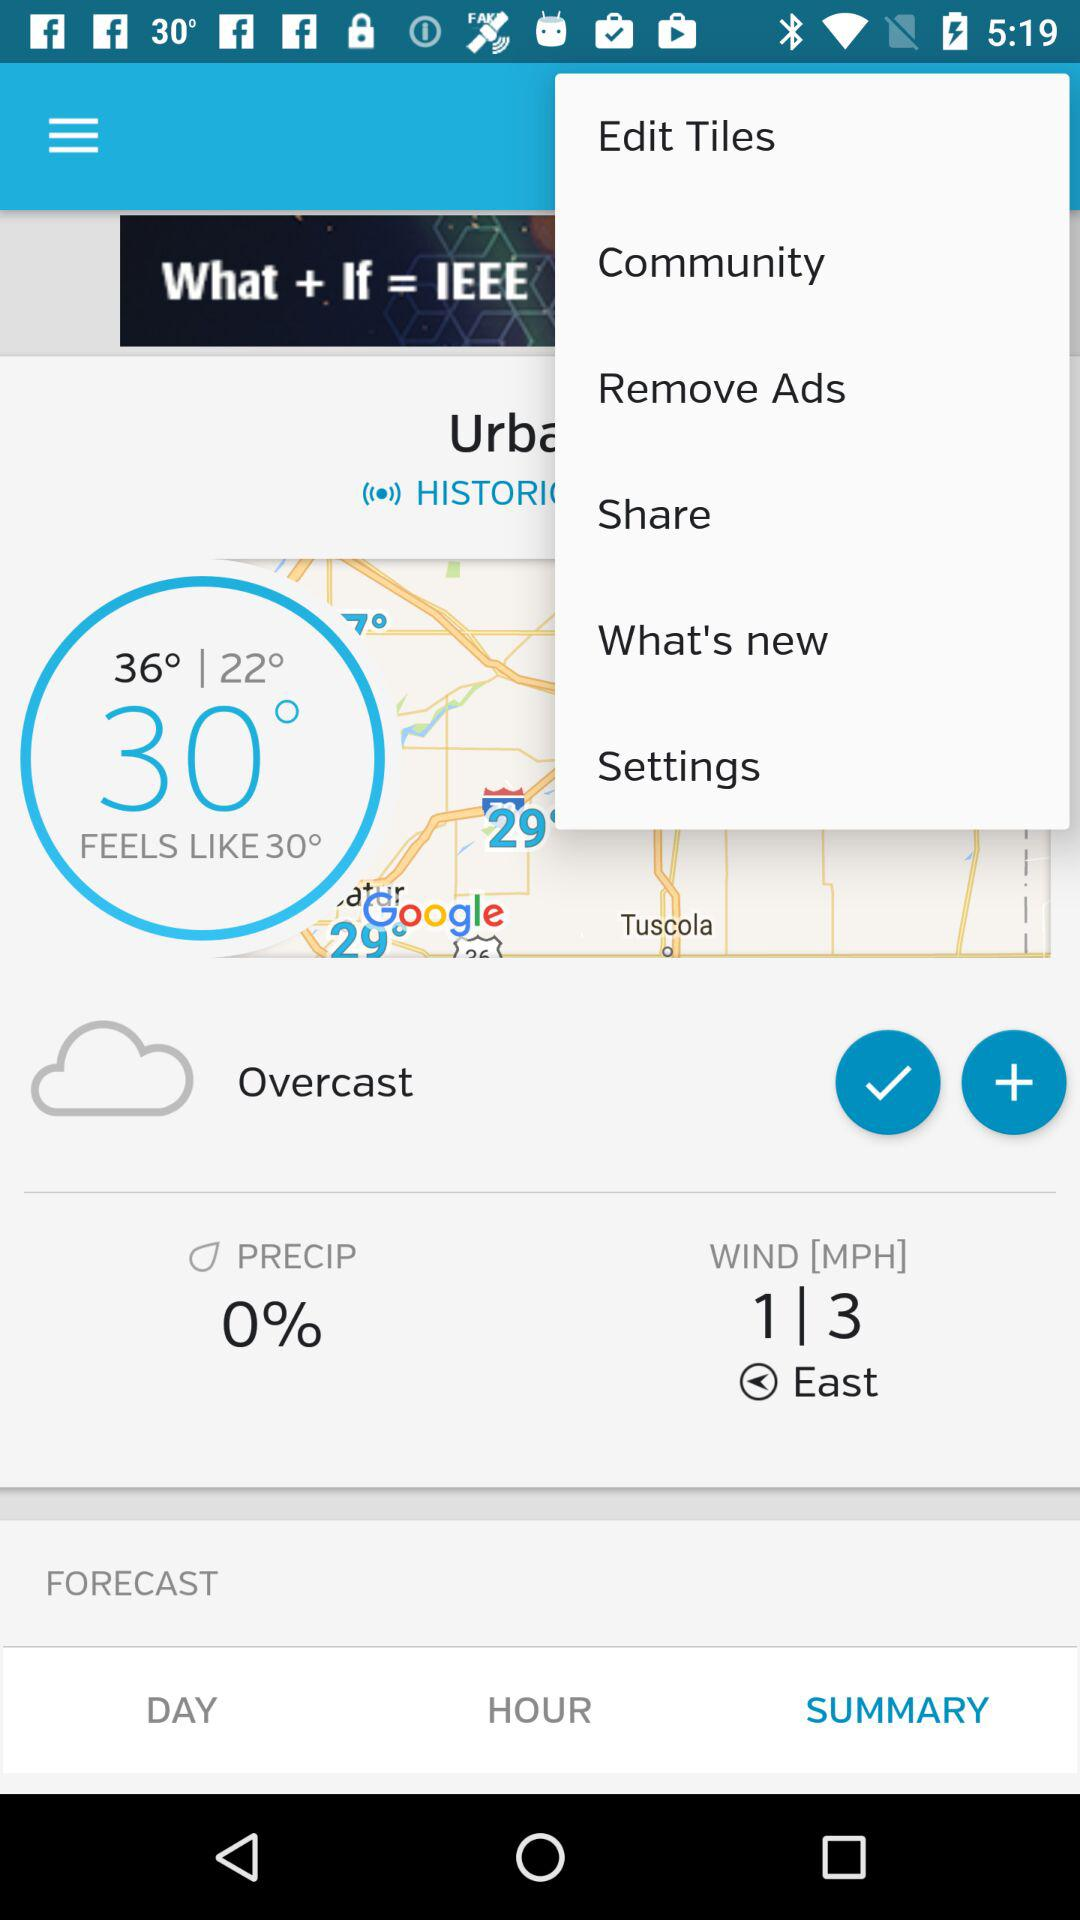What is the wind speed? The wind speed range is 1 to 3 MPH. 